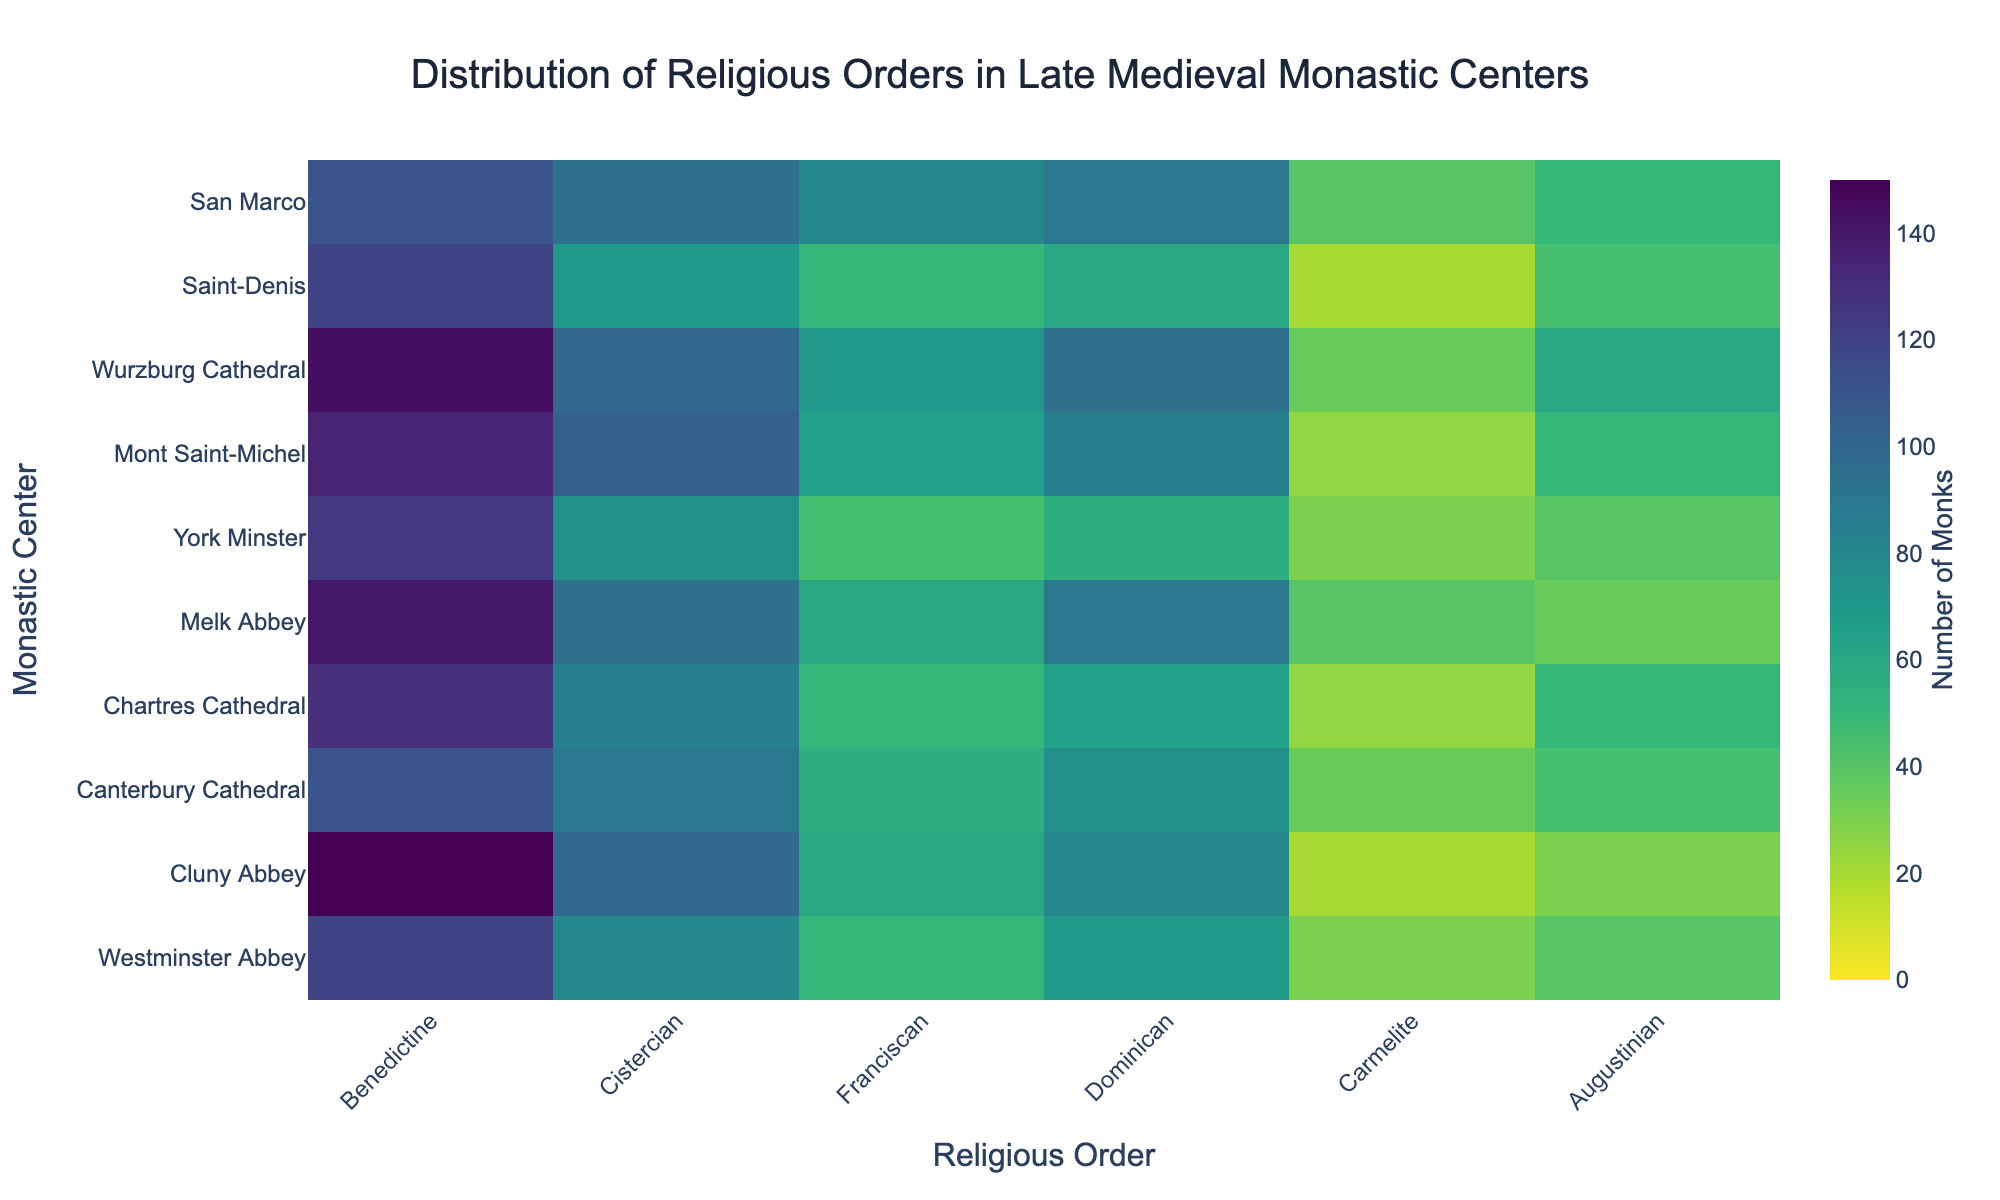What's the title of the figure? The title of the figure is displayed prominently at the top of the plot and reads "Distribution of Religious Orders in Late Medieval Monastic Centers".
Answer: Distribution of Religious Orders in Late Medieval Monastic Centers Which monastic center has the highest number of Benedictine monks? On the y-axis, we can see the monastic centers, and by looking at the z-values for the Benedictine order which are plotted on the x-axis, the highest quantity is at Cluny Abbey with 150 monks.
Answer: Cluny Abbey Which religious order in San Marco has the second highest number of monks? We check the z-values (number of monks) in the row for San Marco. The values are: Benedictine 110, Cistercian 95, Franciscan 80, Dominican 90, Carmelite 40, and Augustinian 50. The second highest number is for Dominican with 90 monks.
Answer: Dominican What is the average number of monks from the Cistercian order at all monastic centers? Sum the number of Cistercian monks across all centers (80 + 100 + 90 + 85 + 95 + 75 + 105 + 100 + 70 + 95) to get 895. There are 10 centers, so divide 895 by 10 to get the average.
Answer: 89.5 Is the number of Franciscan monks in Melk Abbey greater than or equal to those in Chartres Cathedral? Compare the number of Franciscans: Melk Abbey has 60 and Chartres Cathedral has 50. Thus, 60 is greater than 50.
Answer: Yes Which monastic center has the least number of monks in the Carmelite order? Check the z-values for the Carmelite order across all rows. The smallest value is 20 at Cluny Abbey and Saint-Denis.
Answer: Cluny Abbey and Saint-Denis What's the total number of monks in the Benedictine order across all monastic centers? Sum up the Benedictine monks: 120 + 150 + 110 + 130 + 140 + 125 + 135 + 145 + 120 + 110. The total is 1285.
Answer: 1285 How does the number of Dominican monks at Wurzburg Cathedral compare to those at Westminster Abbey? Wurzburg Cathedral has 95 Dominicans, while Westminster Abbey has 70. We see that 95 is greater than 70.
Answer: Wurzburg Cathedral has more Dominican monks than Westminster Abbey What's the range of the number of monks in the Augustinian order across all centers? Find the minimum and maximum values for Augustinian monks. The minimum is 30 (Westminster Abbey) and the maximum is 60 (Wurzburg Cathedral). The range is 60 - 30, which is 30.
Answer: 30 Which religious order is most uniformly distributed across the monastic centers? By visually inspecting the heatmap, we look for the religious order with the least variation across different centers. The Cistercian order shows relatively consistent numbers across most monastic centers.
Answer: Cistercian 